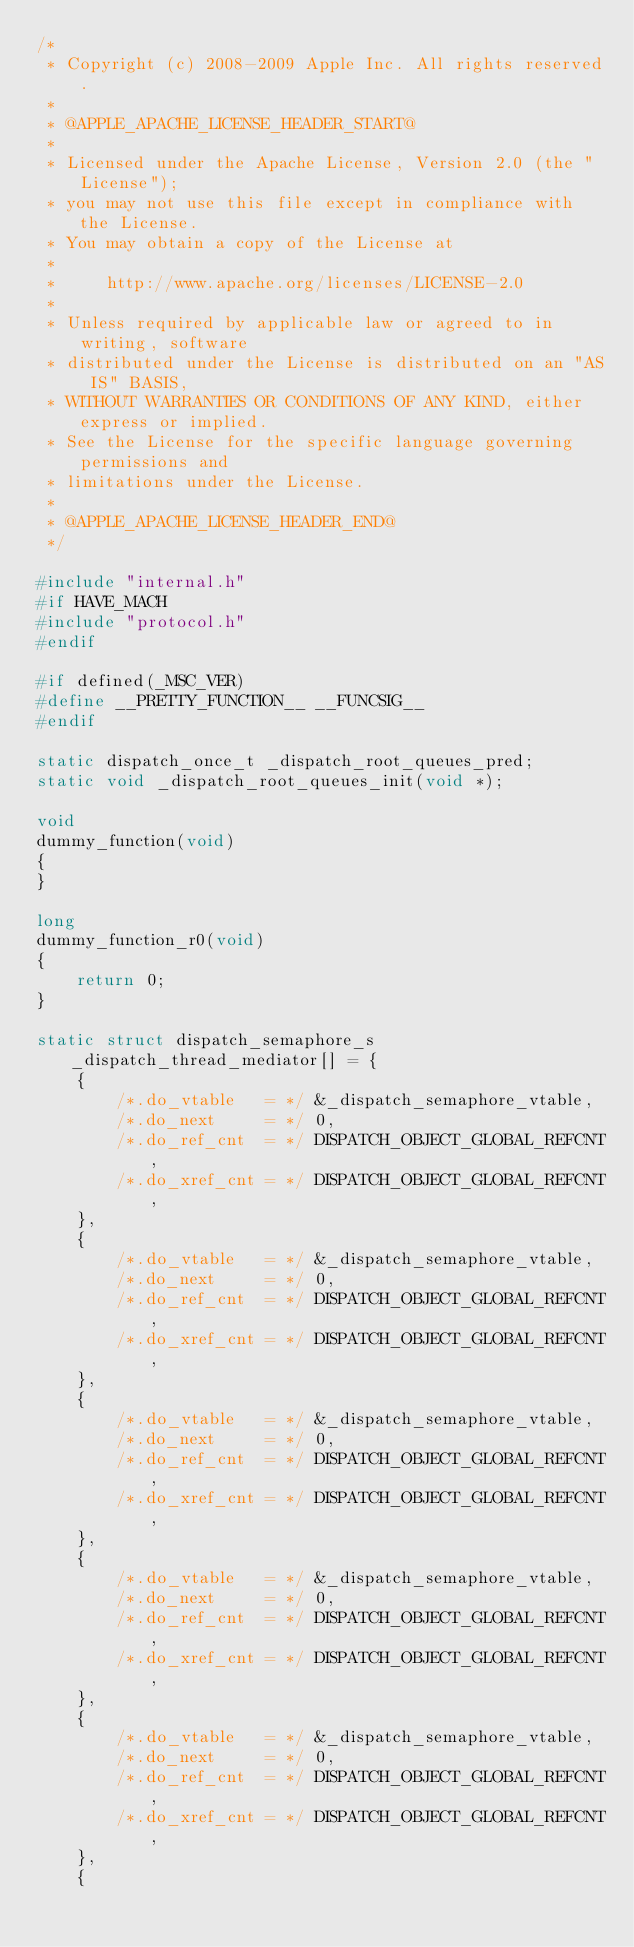<code> <loc_0><loc_0><loc_500><loc_500><_C_>/*
 * Copyright (c) 2008-2009 Apple Inc. All rights reserved.
 *
 * @APPLE_APACHE_LICENSE_HEADER_START@
 * 
 * Licensed under the Apache License, Version 2.0 (the "License");
 * you may not use this file except in compliance with the License.
 * You may obtain a copy of the License at
 * 
 *     http://www.apache.org/licenses/LICENSE-2.0
 * 
 * Unless required by applicable law or agreed to in writing, software
 * distributed under the License is distributed on an "AS IS" BASIS,
 * WITHOUT WARRANTIES OR CONDITIONS OF ANY KIND, either express or implied.
 * See the License for the specific language governing permissions and
 * limitations under the License.
 * 
 * @APPLE_APACHE_LICENSE_HEADER_END@
 */

#include "internal.h"
#if HAVE_MACH
#include "protocol.h"
#endif

#if defined(_MSC_VER)
#define __PRETTY_FUNCTION__ __FUNCSIG__
#endif

static dispatch_once_t _dispatch_root_queues_pred;
static void _dispatch_root_queues_init(void *);

void
dummy_function(void)
{
}

long
dummy_function_r0(void)
{
	return 0;
}

static struct dispatch_semaphore_s _dispatch_thread_mediator[] = {
	{
		/*.do_vtable   = */	&_dispatch_semaphore_vtable,
		/*.do_next     = */	0,
		/*.do_ref_cnt  = */	DISPATCH_OBJECT_GLOBAL_REFCNT,
		/*.do_xref_cnt = */	DISPATCH_OBJECT_GLOBAL_REFCNT,
	},
	{
		/*.do_vtable   = */	&_dispatch_semaphore_vtable,
		/*.do_next     = */	0,
		/*.do_ref_cnt  = */	DISPATCH_OBJECT_GLOBAL_REFCNT,
		/*.do_xref_cnt = */	DISPATCH_OBJECT_GLOBAL_REFCNT,
	},
	{
		/*.do_vtable   = */	&_dispatch_semaphore_vtable,
		/*.do_next     = */	0,
		/*.do_ref_cnt  = */	DISPATCH_OBJECT_GLOBAL_REFCNT,
		/*.do_xref_cnt = */	DISPATCH_OBJECT_GLOBAL_REFCNT,
	},
	{
		/*.do_vtable   = */	&_dispatch_semaphore_vtable,
		/*.do_next     = */	0,
		/*.do_ref_cnt  = */	DISPATCH_OBJECT_GLOBAL_REFCNT,
		/*.do_xref_cnt = */	DISPATCH_OBJECT_GLOBAL_REFCNT,
	},
	{
		/*.do_vtable   = */	&_dispatch_semaphore_vtable,
		/*.do_next     = */	0,
		/*.do_ref_cnt  = */	DISPATCH_OBJECT_GLOBAL_REFCNT,
		/*.do_xref_cnt = */	DISPATCH_OBJECT_GLOBAL_REFCNT,
	},
	{</code> 